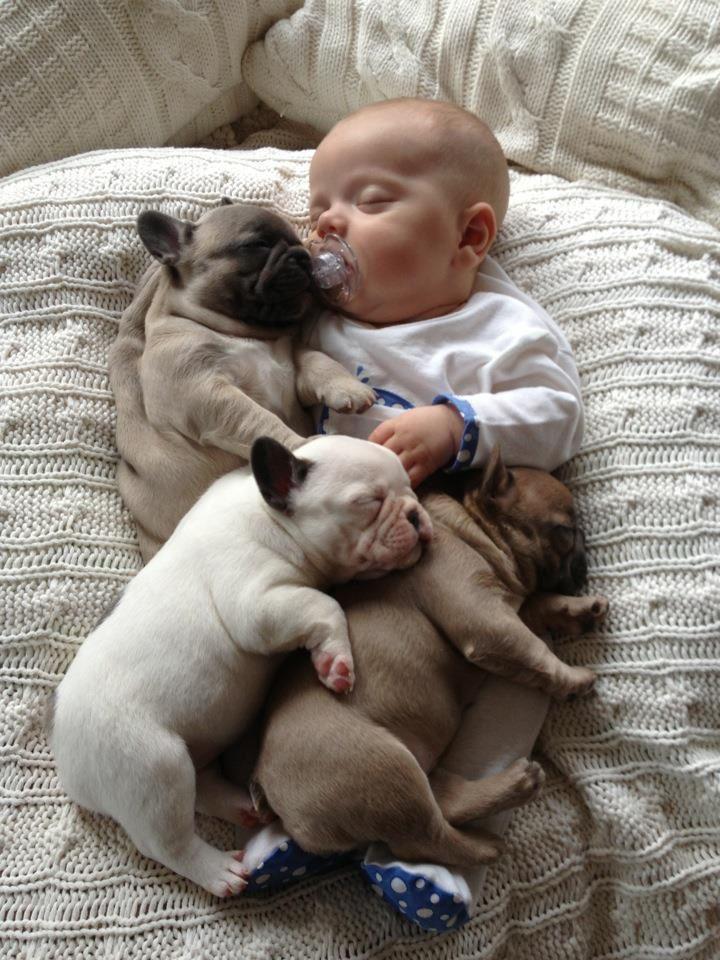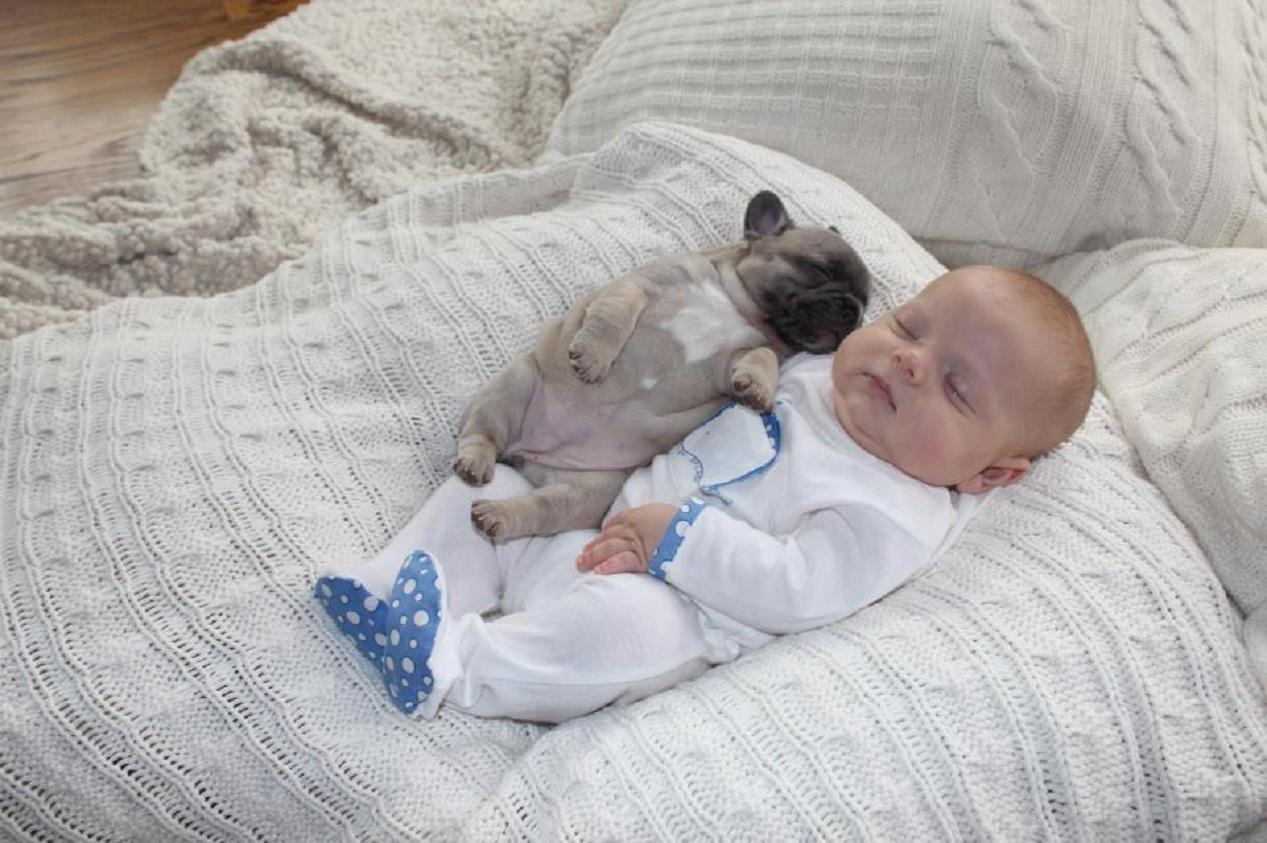The first image is the image on the left, the second image is the image on the right. Assess this claim about the two images: "The right image contains at least three dogs.". Correct or not? Answer yes or no. No. 